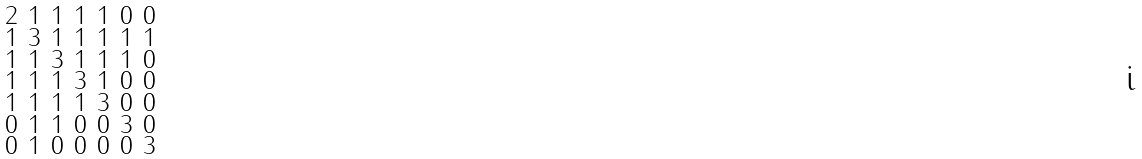Convert formula to latex. <formula><loc_0><loc_0><loc_500><loc_500>\begin{smallmatrix} 2 & 1 & 1 & 1 & 1 & 0 & 0 \\ 1 & 3 & 1 & 1 & 1 & 1 & 1 \\ 1 & 1 & 3 & 1 & 1 & 1 & 0 \\ 1 & 1 & 1 & 3 & 1 & 0 & 0 \\ 1 & 1 & 1 & 1 & 3 & 0 & 0 \\ 0 & 1 & 1 & 0 & 0 & 3 & 0 \\ 0 & 1 & 0 & 0 & 0 & 0 & 3 \end{smallmatrix}</formula> 